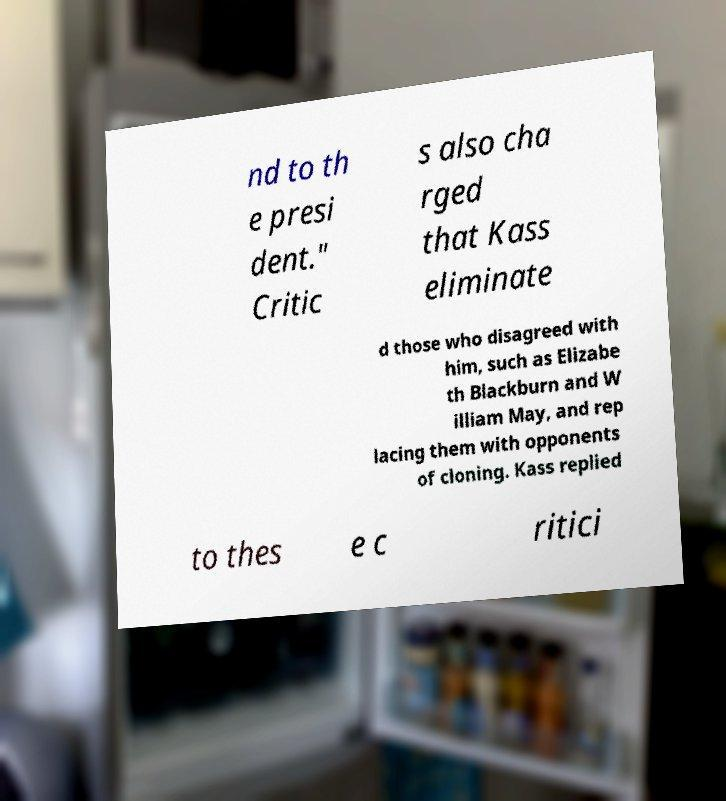Please identify and transcribe the text found in this image. nd to th e presi dent." Critic s also cha rged that Kass eliminate d those who disagreed with him, such as Elizabe th Blackburn and W illiam May, and rep lacing them with opponents of cloning. Kass replied to thes e c ritici 